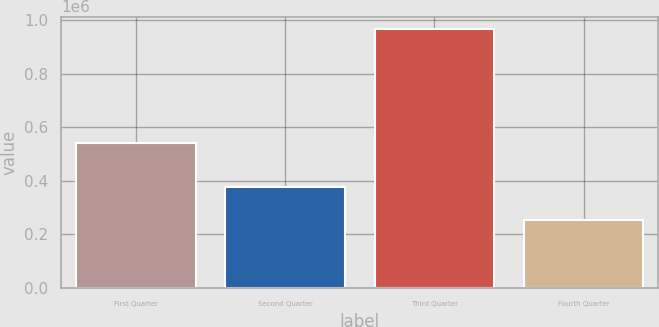<chart> <loc_0><loc_0><loc_500><loc_500><bar_chart><fcel>First Quarter<fcel>Second Quarter<fcel>Third Quarter<fcel>Fourth Quarter<nl><fcel>542769<fcel>377383<fcel>965016<fcel>254300<nl></chart> 